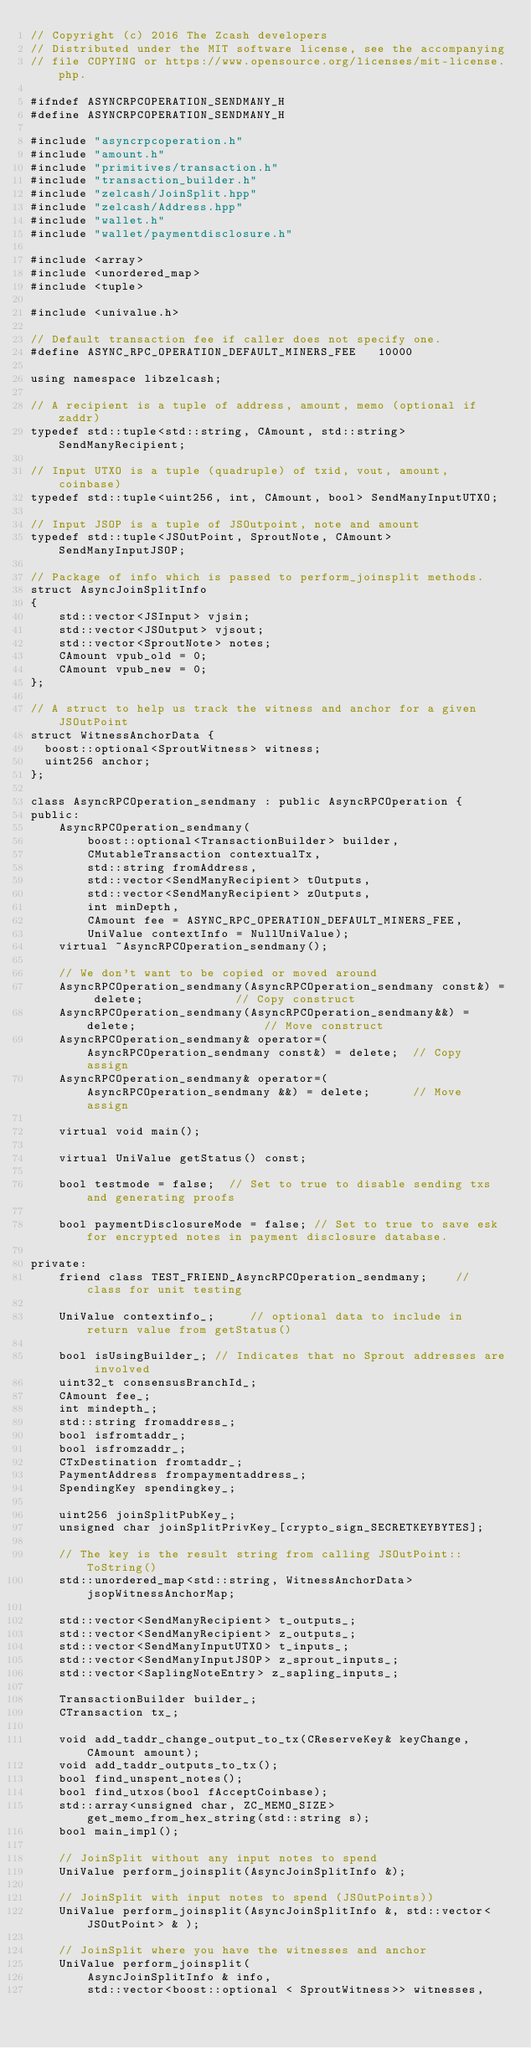Convert code to text. <code><loc_0><loc_0><loc_500><loc_500><_C_>// Copyright (c) 2016 The Zcash developers
// Distributed under the MIT software license, see the accompanying
// file COPYING or https://www.opensource.org/licenses/mit-license.php.

#ifndef ASYNCRPCOPERATION_SENDMANY_H
#define ASYNCRPCOPERATION_SENDMANY_H

#include "asyncrpcoperation.h"
#include "amount.h"
#include "primitives/transaction.h"
#include "transaction_builder.h"
#include "zelcash/JoinSplit.hpp"
#include "zelcash/Address.hpp"
#include "wallet.h"
#include "wallet/paymentdisclosure.h"

#include <array>
#include <unordered_map>
#include <tuple>

#include <univalue.h>

// Default transaction fee if caller does not specify one.
#define ASYNC_RPC_OPERATION_DEFAULT_MINERS_FEE   10000

using namespace libzelcash;

// A recipient is a tuple of address, amount, memo (optional if zaddr)
typedef std::tuple<std::string, CAmount, std::string> SendManyRecipient;

// Input UTXO is a tuple (quadruple) of txid, vout, amount, coinbase)
typedef std::tuple<uint256, int, CAmount, bool> SendManyInputUTXO;

// Input JSOP is a tuple of JSOutpoint, note and amount
typedef std::tuple<JSOutPoint, SproutNote, CAmount> SendManyInputJSOP;

// Package of info which is passed to perform_joinsplit methods.
struct AsyncJoinSplitInfo
{
    std::vector<JSInput> vjsin;
    std::vector<JSOutput> vjsout;
    std::vector<SproutNote> notes;
    CAmount vpub_old = 0;
    CAmount vpub_new = 0;
};

// A struct to help us track the witness and anchor for a given JSOutPoint
struct WitnessAnchorData {
	boost::optional<SproutWitness> witness;
	uint256 anchor;
};

class AsyncRPCOperation_sendmany : public AsyncRPCOperation {
public:
    AsyncRPCOperation_sendmany(
        boost::optional<TransactionBuilder> builder,
        CMutableTransaction contextualTx,
        std::string fromAddress,
        std::vector<SendManyRecipient> tOutputs,
        std::vector<SendManyRecipient> zOutputs,
        int minDepth,
        CAmount fee = ASYNC_RPC_OPERATION_DEFAULT_MINERS_FEE,
        UniValue contextInfo = NullUniValue);
    virtual ~AsyncRPCOperation_sendmany();
    
    // We don't want to be copied or moved around
    AsyncRPCOperation_sendmany(AsyncRPCOperation_sendmany const&) = delete;             // Copy construct
    AsyncRPCOperation_sendmany(AsyncRPCOperation_sendmany&&) = delete;                  // Move construct
    AsyncRPCOperation_sendmany& operator=(AsyncRPCOperation_sendmany const&) = delete;  // Copy assign
    AsyncRPCOperation_sendmany& operator=(AsyncRPCOperation_sendmany &&) = delete;      // Move assign
    
    virtual void main();

    virtual UniValue getStatus() const;

    bool testmode = false;  // Set to true to disable sending txs and generating proofs

    bool paymentDisclosureMode = false; // Set to true to save esk for encrypted notes in payment disclosure database.

private:
    friend class TEST_FRIEND_AsyncRPCOperation_sendmany;    // class for unit testing

    UniValue contextinfo_;     // optional data to include in return value from getStatus()

    bool isUsingBuilder_; // Indicates that no Sprout addresses are involved
    uint32_t consensusBranchId_;
    CAmount fee_;
    int mindepth_;
    std::string fromaddress_;
    bool isfromtaddr_;
    bool isfromzaddr_;
    CTxDestination fromtaddr_;
    PaymentAddress frompaymentaddress_;
    SpendingKey spendingkey_;
    
    uint256 joinSplitPubKey_;
    unsigned char joinSplitPrivKey_[crypto_sign_SECRETKEYBYTES];

    // The key is the result string from calling JSOutPoint::ToString()
    std::unordered_map<std::string, WitnessAnchorData> jsopWitnessAnchorMap;

    std::vector<SendManyRecipient> t_outputs_;
    std::vector<SendManyRecipient> z_outputs_;
    std::vector<SendManyInputUTXO> t_inputs_;
    std::vector<SendManyInputJSOP> z_sprout_inputs_;
    std::vector<SaplingNoteEntry> z_sapling_inputs_;

    TransactionBuilder builder_;
    CTransaction tx_;

    void add_taddr_change_output_to_tx(CReserveKey& keyChange, CAmount amount);
    void add_taddr_outputs_to_tx();
    bool find_unspent_notes();
    bool find_utxos(bool fAcceptCoinbase);
    std::array<unsigned char, ZC_MEMO_SIZE> get_memo_from_hex_string(std::string s);
    bool main_impl();

    // JoinSplit without any input notes to spend
    UniValue perform_joinsplit(AsyncJoinSplitInfo &);

    // JoinSplit with input notes to spend (JSOutPoints))
    UniValue perform_joinsplit(AsyncJoinSplitInfo &, std::vector<JSOutPoint> & );

    // JoinSplit where you have the witnesses and anchor
    UniValue perform_joinsplit(
        AsyncJoinSplitInfo & info,
        std::vector<boost::optional < SproutWitness>> witnesses,</code> 